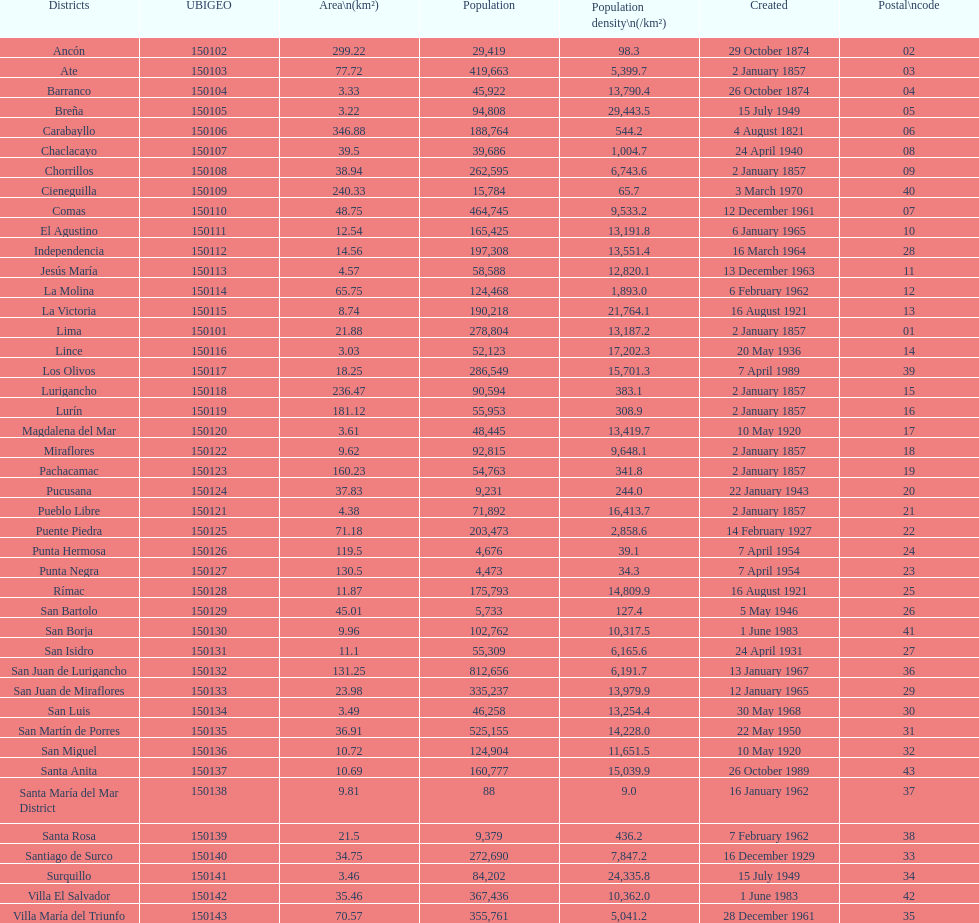Help me parse the entirety of this table. {'header': ['Districts', 'UBIGEO', 'Area\\n(km²)', 'Population', 'Population density\\n(/km²)', 'Created', 'Postal\\ncode'], 'rows': [['Ancón', '150102', '299.22', '29,419', '98.3', '29 October 1874', '02'], ['Ate', '150103', '77.72', '419,663', '5,399.7', '2 January 1857', '03'], ['Barranco', '150104', '3.33', '45,922', '13,790.4', '26 October 1874', '04'], ['Breña', '150105', '3.22', '94,808', '29,443.5', '15 July 1949', '05'], ['Carabayllo', '150106', '346.88', '188,764', '544.2', '4 August 1821', '06'], ['Chaclacayo', '150107', '39.5', '39,686', '1,004.7', '24 April 1940', '08'], ['Chorrillos', '150108', '38.94', '262,595', '6,743.6', '2 January 1857', '09'], ['Cieneguilla', '150109', '240.33', '15,784', '65.7', '3 March 1970', '40'], ['Comas', '150110', '48.75', '464,745', '9,533.2', '12 December 1961', '07'], ['El Agustino', '150111', '12.54', '165,425', '13,191.8', '6 January 1965', '10'], ['Independencia', '150112', '14.56', '197,308', '13,551.4', '16 March 1964', '28'], ['Jesús María', '150113', '4.57', '58,588', '12,820.1', '13 December 1963', '11'], ['La Molina', '150114', '65.75', '124,468', '1,893.0', '6 February 1962', '12'], ['La Victoria', '150115', '8.74', '190,218', '21,764.1', '16 August 1921', '13'], ['Lima', '150101', '21.88', '278,804', '13,187.2', '2 January 1857', '01'], ['Lince', '150116', '3.03', '52,123', '17,202.3', '20 May 1936', '14'], ['Los Olivos', '150117', '18.25', '286,549', '15,701.3', '7 April 1989', '39'], ['Lurigancho', '150118', '236.47', '90,594', '383.1', '2 January 1857', '15'], ['Lurín', '150119', '181.12', '55,953', '308.9', '2 January 1857', '16'], ['Magdalena del Mar', '150120', '3.61', '48,445', '13,419.7', '10 May 1920', '17'], ['Miraflores', '150122', '9.62', '92,815', '9,648.1', '2 January 1857', '18'], ['Pachacamac', '150123', '160.23', '54,763', '341.8', '2 January 1857', '19'], ['Pucusana', '150124', '37.83', '9,231', '244.0', '22 January 1943', '20'], ['Pueblo Libre', '150121', '4.38', '71,892', '16,413.7', '2 January 1857', '21'], ['Puente Piedra', '150125', '71.18', '203,473', '2,858.6', '14 February 1927', '22'], ['Punta Hermosa', '150126', '119.5', '4,676', '39.1', '7 April 1954', '24'], ['Punta Negra', '150127', '130.5', '4,473', '34.3', '7 April 1954', '23'], ['Rímac', '150128', '11.87', '175,793', '14,809.9', '16 August 1921', '25'], ['San Bartolo', '150129', '45.01', '5,733', '127.4', '5 May 1946', '26'], ['San Borja', '150130', '9.96', '102,762', '10,317.5', '1 June 1983', '41'], ['San Isidro', '150131', '11.1', '55,309', '6,165.6', '24 April 1931', '27'], ['San Juan de Lurigancho', '150132', '131.25', '812,656', '6,191.7', '13 January 1967', '36'], ['San Juan de Miraflores', '150133', '23.98', '335,237', '13,979.9', '12 January 1965', '29'], ['San Luis', '150134', '3.49', '46,258', '13,254.4', '30 May 1968', '30'], ['San Martín de Porres', '150135', '36.91', '525,155', '14,228.0', '22 May 1950', '31'], ['San Miguel', '150136', '10.72', '124,904', '11,651.5', '10 May 1920', '32'], ['Santa Anita', '150137', '10.69', '160,777', '15,039.9', '26 October 1989', '43'], ['Santa María del Mar District', '150138', '9.81', '88', '9.0', '16 January 1962', '37'], ['Santa Rosa', '150139', '21.5', '9,379', '436.2', '7 February 1962', '38'], ['Santiago de Surco', '150140', '34.75', '272,690', '7,847.2', '16 December 1929', '33'], ['Surquillo', '150141', '3.46', '84,202', '24,335.8', '15 July 1949', '34'], ['Villa El Salvador', '150142', '35.46', '367,436', '10,362.0', '1 June 1983', '42'], ['Villa María del Triunfo', '150143', '70.57', '355,761', '5,041.2', '28 December 1961', '35']]} In which district is the population the smallest? Santa María del Mar District. 